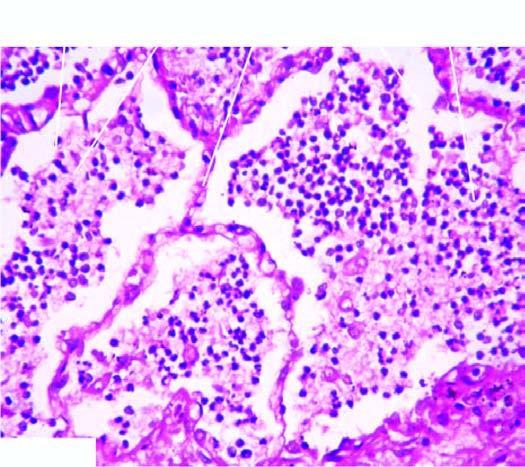what is composed of neutrophils and macrophages?
Answer the question using a single word or phrase. Nfiltrate in the lumina 